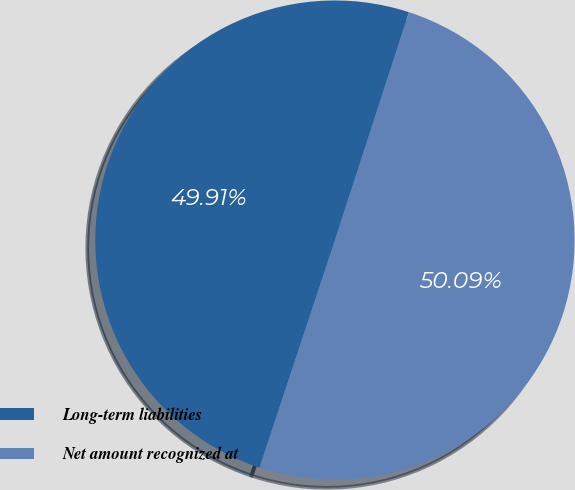Convert chart to OTSL. <chart><loc_0><loc_0><loc_500><loc_500><pie_chart><fcel>Long-term liabilities<fcel>Net amount recognized at<nl><fcel>49.91%<fcel>50.09%<nl></chart> 